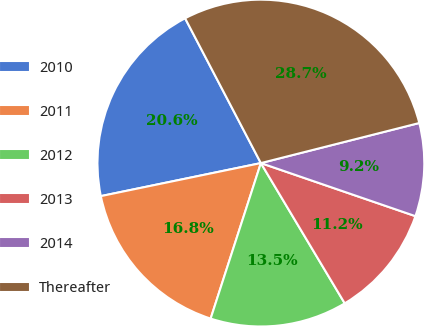<chart> <loc_0><loc_0><loc_500><loc_500><pie_chart><fcel>2010<fcel>2011<fcel>2012<fcel>2013<fcel>2014<fcel>Thereafter<nl><fcel>20.57%<fcel>16.79%<fcel>13.55%<fcel>11.16%<fcel>9.21%<fcel>28.73%<nl></chart> 